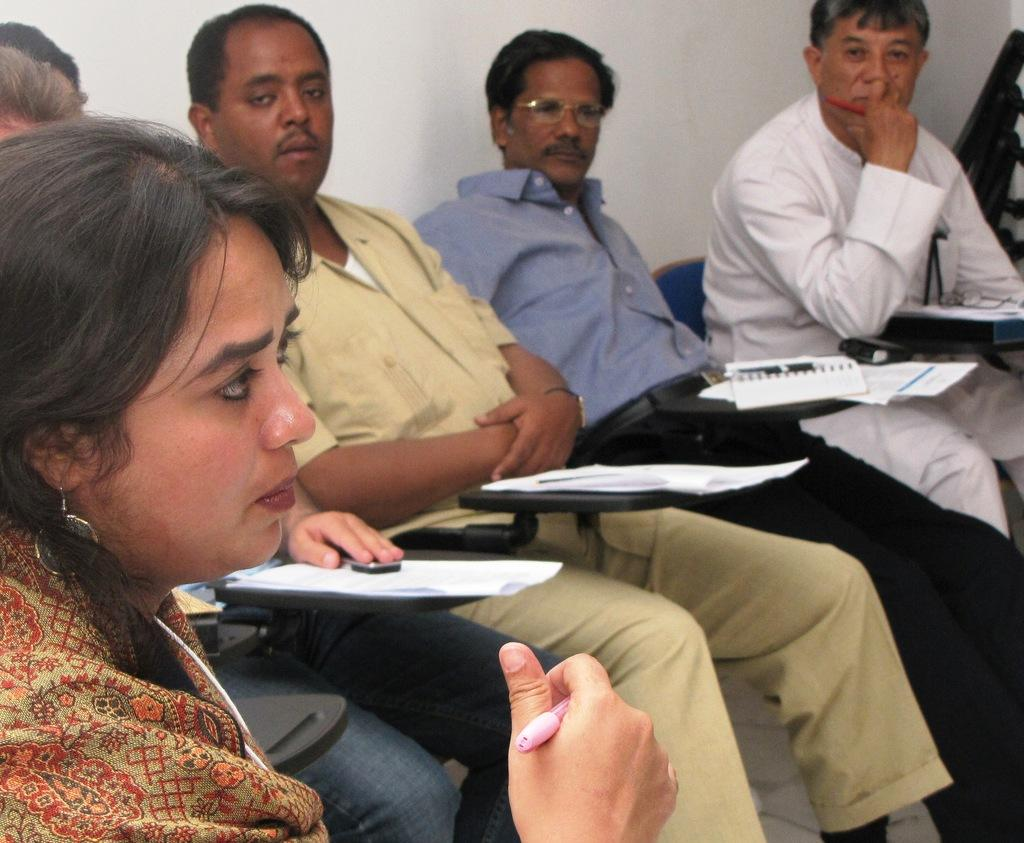What types of people are in the image? There are men and women in the image. What are the men and women doing in the image? The men and women are sitting on chairs. What objects can be seen in the image besides the people? There are papers in the image. What is visible in the background of the image? There is a wall in the image. Can you see a roof in the image? There is no roof visible in the image; only a wall is present in the background. 